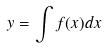Convert formula to latex. <formula><loc_0><loc_0><loc_500><loc_500>y = \int f ( x ) d x</formula> 